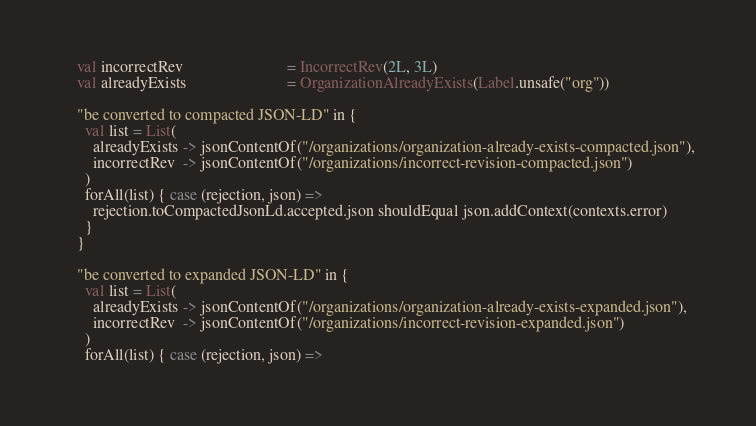Convert code to text. <code><loc_0><loc_0><loc_500><loc_500><_Scala_>    val incorrectRev                          = IncorrectRev(2L, 3L)
    val alreadyExists                         = OrganizationAlreadyExists(Label.unsafe("org"))

    "be converted to compacted JSON-LD" in {
      val list = List(
        alreadyExists -> jsonContentOf("/organizations/organization-already-exists-compacted.json"),
        incorrectRev  -> jsonContentOf("/organizations/incorrect-revision-compacted.json")
      )
      forAll(list) { case (rejection, json) =>
        rejection.toCompactedJsonLd.accepted.json shouldEqual json.addContext(contexts.error)
      }
    }

    "be converted to expanded JSON-LD" in {
      val list = List(
        alreadyExists -> jsonContentOf("/organizations/organization-already-exists-expanded.json"),
        incorrectRev  -> jsonContentOf("/organizations/incorrect-revision-expanded.json")
      )
      forAll(list) { case (rejection, json) =></code> 